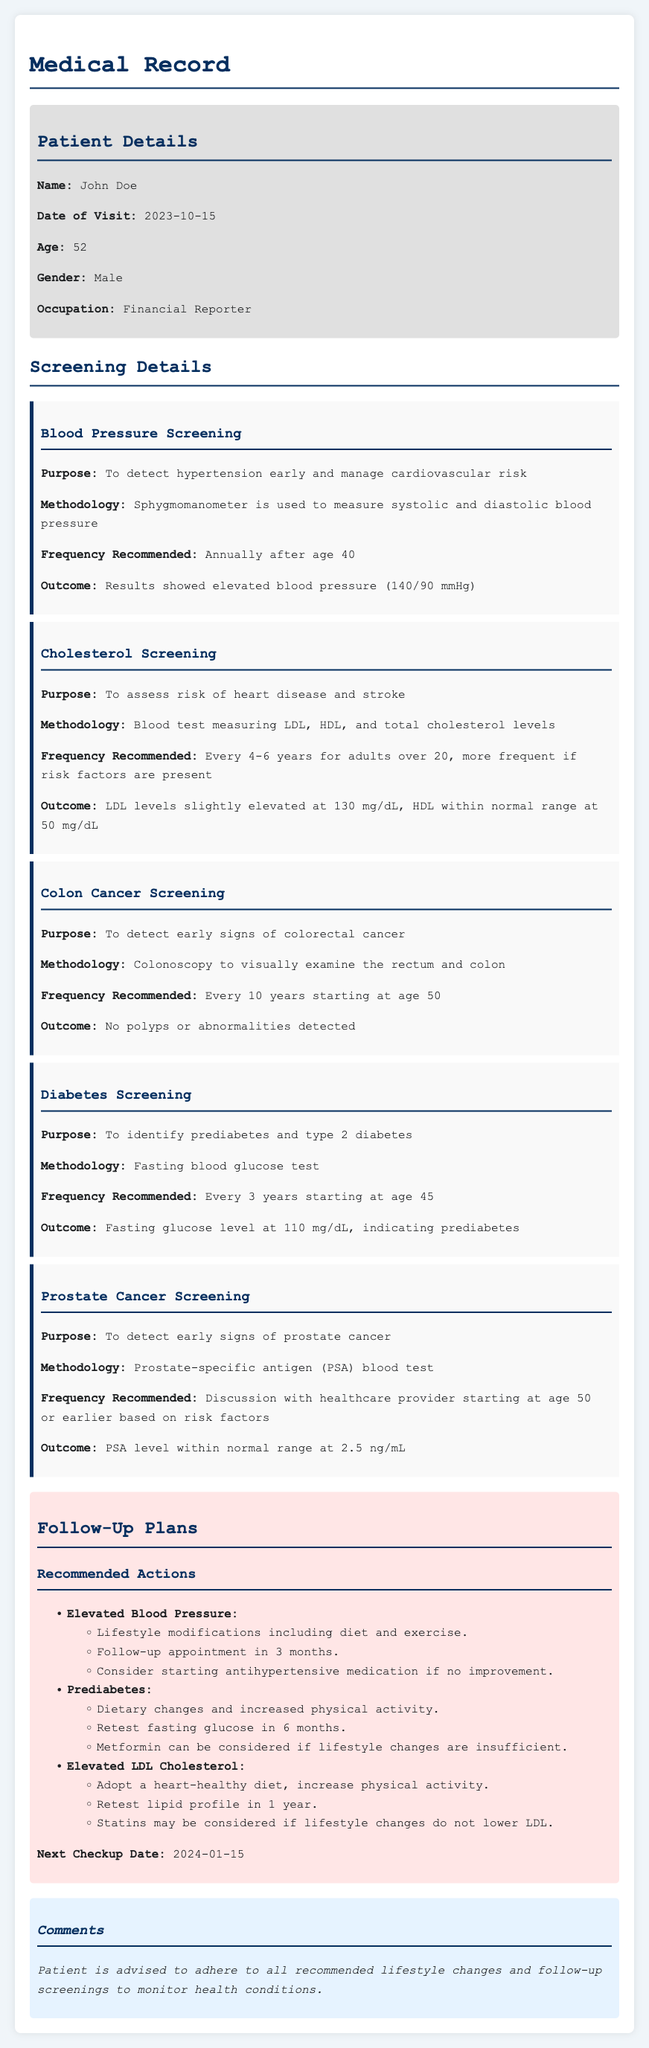What is the patient's name? The patient's name is mentioned in the "Patient Details" section of the document.
Answer: John Doe What is the date of visit? The date of visit is clearly stated in the "Patient Details" section.
Answer: 2023-10-15 What was the outcome of the cholesterol screening? The outcome is provided in the "Cholesterol Screening" section, which indicates the patient's cholesterol levels.
Answer: LDL levels slightly elevated at 130 mg/dL What lifestyle modifications are recommended for elevated blood pressure? The recommendations for elevated blood pressure can be found under the "Recommended Actions" section related to blood pressure.
Answer: Diet and exercise How often should diabetes screening be conducted starting at age 45? The frequency is provided in the "Diabetes Screening" section where screening recommendations are outlined.
Answer: Every 3 years What is the follow-up appointment timeframe for elevated LDL cholesterol? The timeframe for follow-up is specified in the "Follow-Up Plans" section regarding elevated LDL cholesterol.
Answer: 1 year What is the recommended frequency for blood pressure screening? The frequency for blood pressure screening is mentioned in the "Blood Pressure Screening" section.
Answer: Annually after age 40 What was the overall recommendation for the patient's follow-up care? The overall recommendation can be summarized from the "Comments" section at the end of the document.
Answer: Adhere to all recommended lifestyle changes and follow-up screenings 